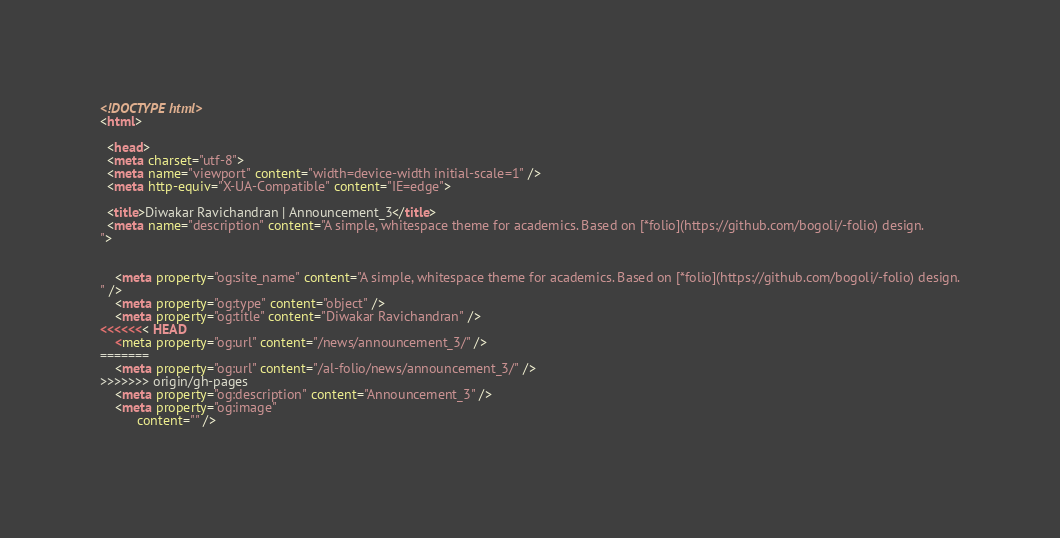Convert code to text. <code><loc_0><loc_0><loc_500><loc_500><_HTML_><!DOCTYPE html>
<html>

  <head>
  <meta charset="utf-8">
  <meta name="viewport" content="width=device-width initial-scale=1" />
  <meta http-equiv="X-UA-Compatible" content="IE=edge">

  <title>Diwakar Ravichandran | Announcement_3</title>
  <meta name="description" content="A simple, whitespace theme for academics. Based on [*folio](https://github.com/bogoli/-folio) design.
">

  
    <meta property="og:site_name" content="A simple, whitespace theme for academics. Based on [*folio](https://github.com/bogoli/-folio) design.
" />
    <meta property="og:type" content="object" />
    <meta property="og:title" content="Diwakar Ravichandran" />
<<<<<<< HEAD
    <meta property="og:url" content="/news/announcement_3/" />
=======
    <meta property="og:url" content="/al-folio/news/announcement_3/" />
>>>>>>> origin/gh-pages
    <meta property="og:description" content="Announcement_3" />
    <meta property="og:image"
          content="" />
  
</code> 